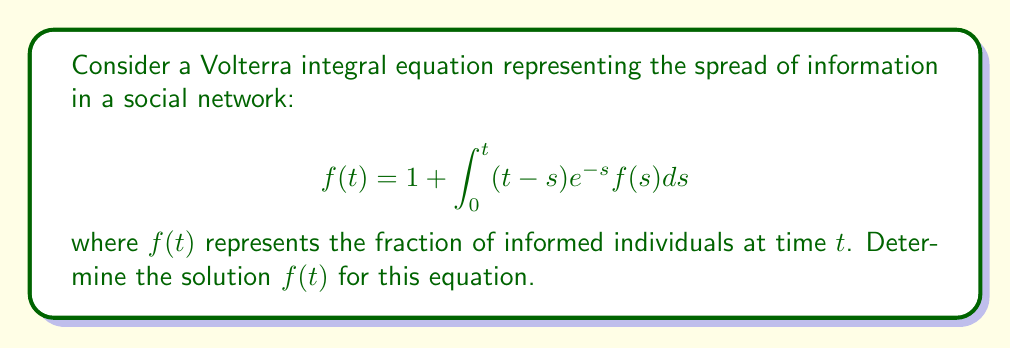Can you solve this math problem? To solve this Volterra integral equation, we'll use the Laplace transform method:

1) Take the Laplace transform of both sides:
   $$\mathcal{L}\{f(t)\} = \mathcal{L}\{1\} + \mathcal{L}\{\int_0^t (t-s)e^{-s}f(s)ds\}$$

2) Using Laplace transform properties:
   $$F(p) = \frac{1}{p} + \mathcal{L}\{(t-s)e^{-s}\} \cdot F(p)$$

3) Compute $\mathcal{L}\{(t-s)e^{-s}\}$:
   $$\mathcal{L}\{(t-s)e^{-s}\} = \frac{1}{(p+1)^2}$$

4) Substitute back:
   $$F(p) = \frac{1}{p} + \frac{1}{(p+1)^2}F(p)$$

5) Solve for $F(p)$:
   $$F(p) = \frac{1}{p} + \frac{F(p)}{(p+1)^2}$$
   $$F(p)\left(1 - \frac{1}{(p+1)^2}\right) = \frac{1}{p}$$
   $$F(p) = \frac{(p+1)^2}{p((p+1)^2-1)} = \frac{(p+1)^2}{p(p^2+2p)}$$

6) Decompose into partial fractions:
   $$F(p) = \frac{1}{p} + \frac{2}{p+2}$$

7) Take the inverse Laplace transform:
   $$f(t) = 1 + 2e^{-2t}$$

Therefore, the solution to the Volterra integral equation is $f(t) = 1 + 2e^{-2t}$.
Answer: $f(t) = 1 + 2e^{-2t}$ 